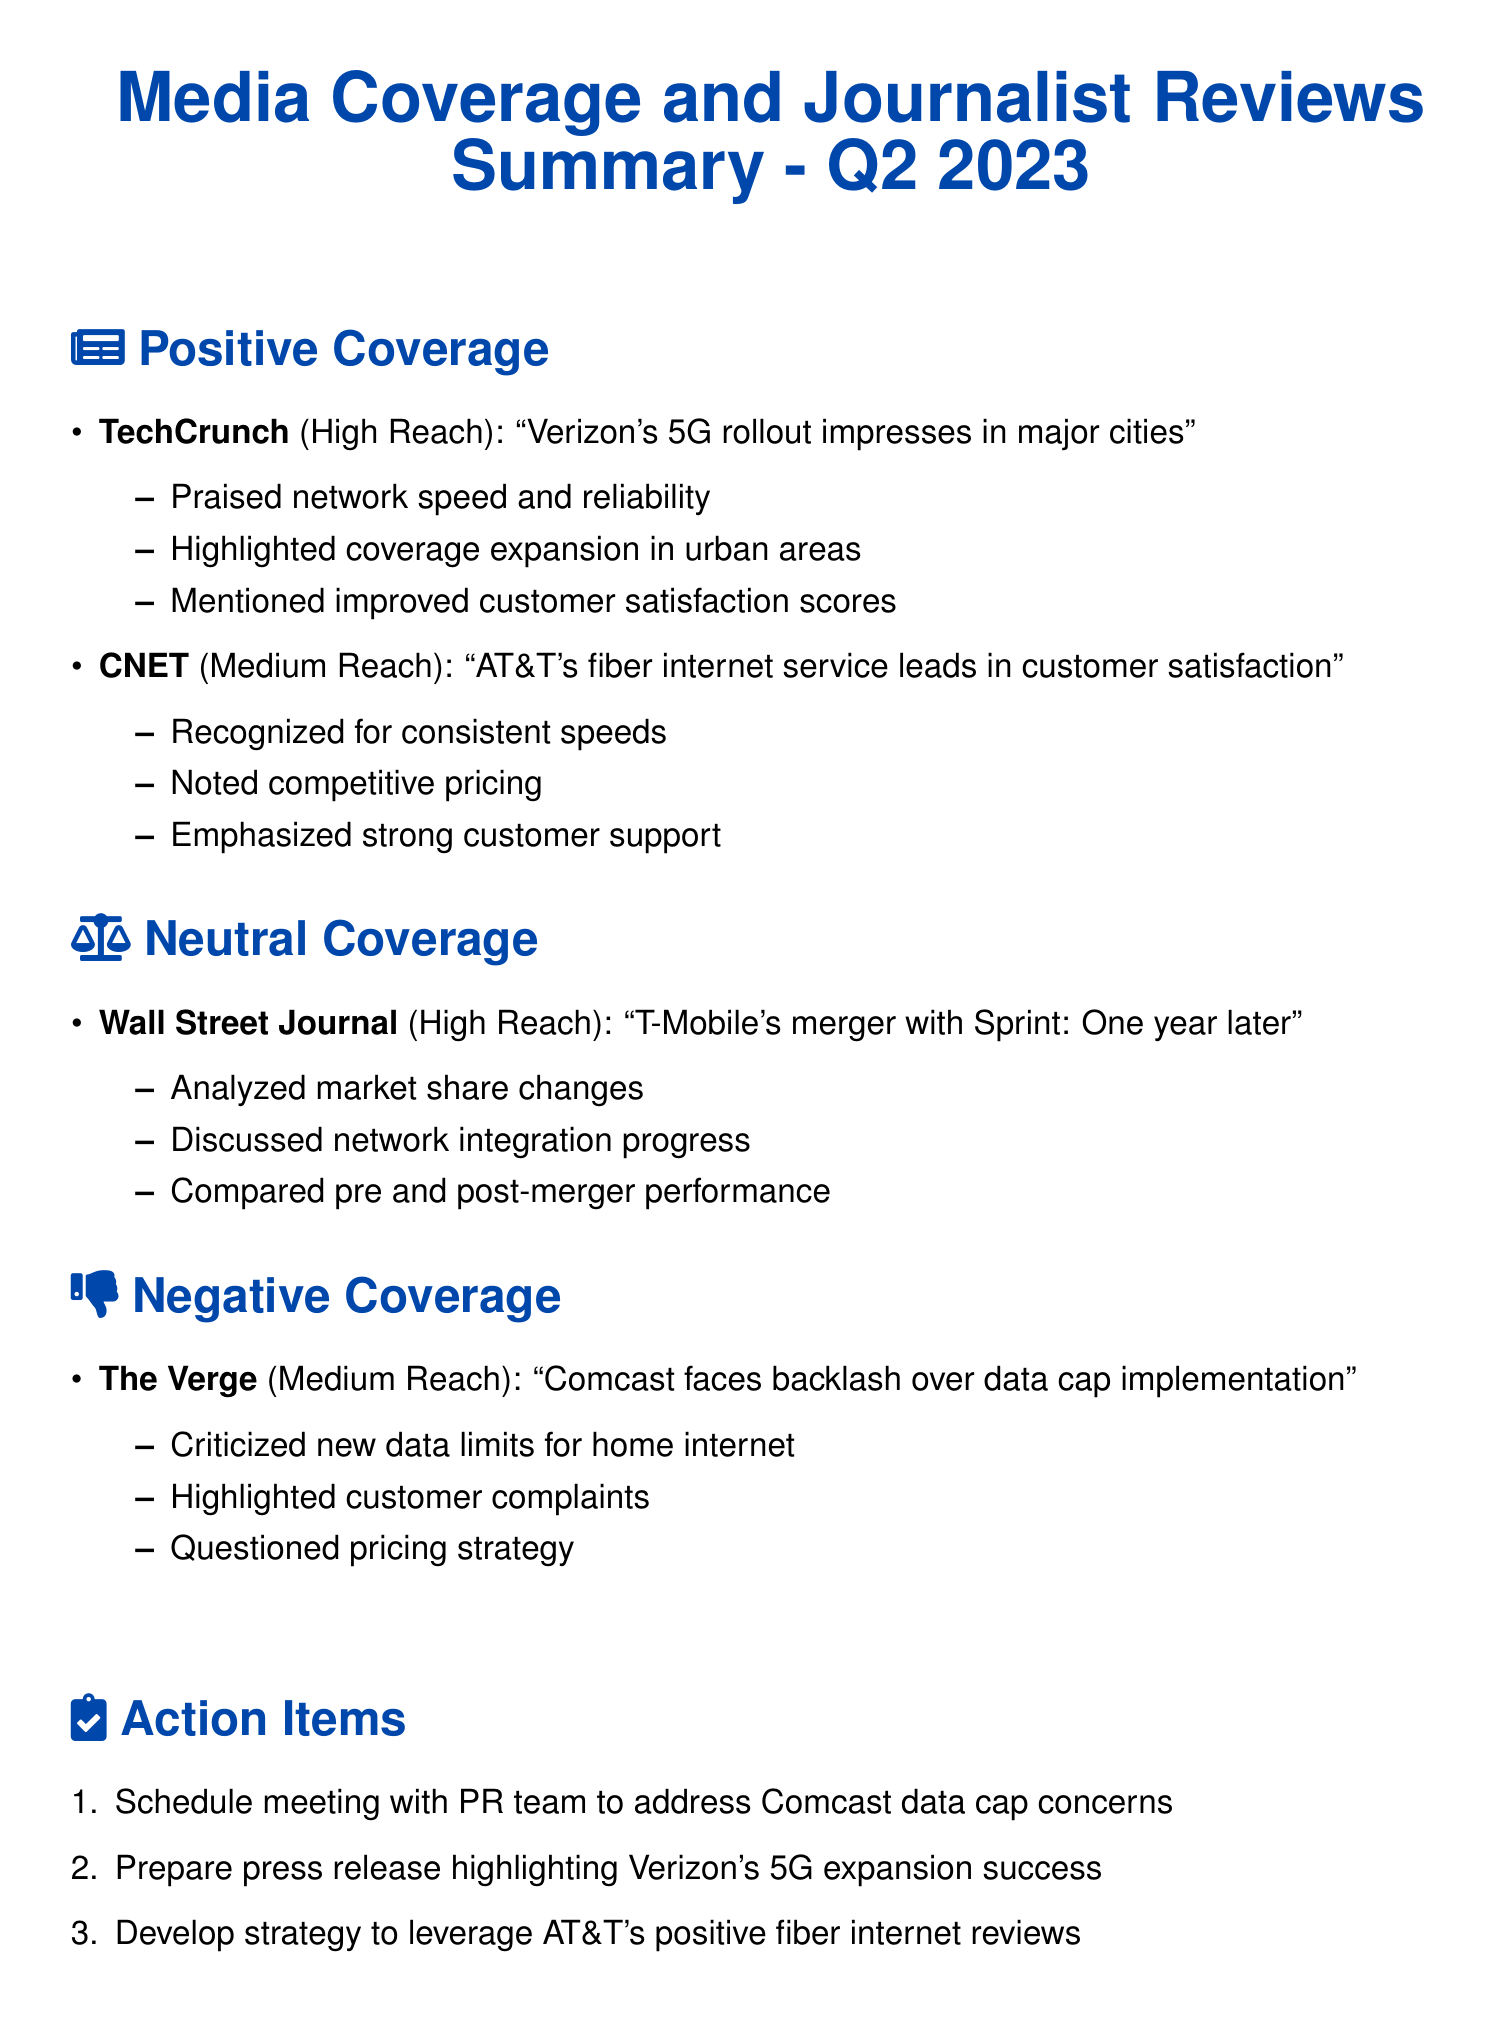what is the title of the document? The title is found at the top center of the document, indicating the content's focus and time period.
Answer: Media Coverage and Journalist Reviews Summary - Q2 2023 which publication praised Verizon's 5G rollout? The document lists TechCrunch as the publication providing positive coverage of Verizon's 5G rollout.
Answer: TechCrunch how many action items are listed in the document? The document enumerates action items related to media coverage and journalist reviews, providing a count.
Answer: 3 what is the sentiment of the coverage by The Verge? The sentiment is indicated by the categorization in the document, which provides a clear classification.
Answer: Negative who leads in customer satisfaction according to CNET? The positive coverage by CNET specifically mentions AT&T's achievement concerning customer satisfaction.
Answer: AT&T what type of coverage does the Wall Street Journal provide? The document categorizes coverage types, which helps identify the nature of the publication's content.
Answer: Neutral what is the main issue raised in The Verge's article? The document summarizes the criticism outlined in the article by highlighting the specific complaint addressed.
Answer: Data cap which company is highlighted for its strong customer support? CNET's coverage emphasizes a particular organization's strong customer support as a notable point.
Answer: AT&T 